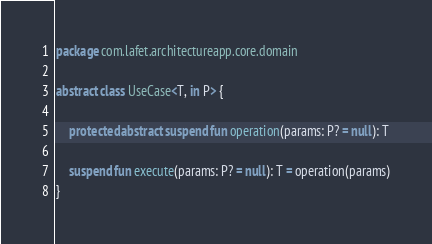Convert code to text. <code><loc_0><loc_0><loc_500><loc_500><_Kotlin_>package com.lafet.architectureapp.core.domain

abstract class UseCase<T, in P> {

    protected abstract suspend fun operation(params: P? = null): T

    suspend fun execute(params: P? = null): T = operation(params)
}</code> 